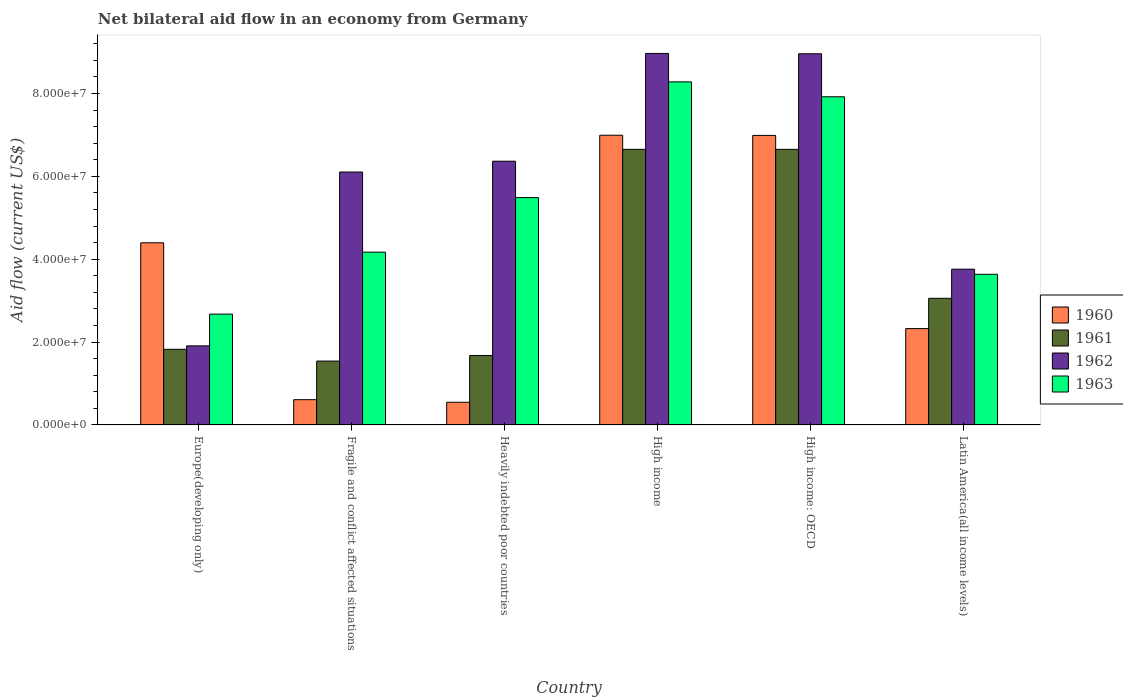How many groups of bars are there?
Your response must be concise. 6. How many bars are there on the 1st tick from the right?
Offer a terse response. 4. What is the label of the 6th group of bars from the left?
Provide a short and direct response. Latin America(all income levels). In how many cases, is the number of bars for a given country not equal to the number of legend labels?
Give a very brief answer. 0. What is the net bilateral aid flow in 1963 in Europe(developing only)?
Your response must be concise. 2.67e+07. Across all countries, what is the maximum net bilateral aid flow in 1962?
Offer a very short reply. 8.97e+07. Across all countries, what is the minimum net bilateral aid flow in 1961?
Ensure brevity in your answer.  1.54e+07. In which country was the net bilateral aid flow in 1960 maximum?
Offer a terse response. High income. In which country was the net bilateral aid flow in 1962 minimum?
Provide a succinct answer. Europe(developing only). What is the total net bilateral aid flow in 1960 in the graph?
Keep it short and to the point. 2.19e+08. What is the difference between the net bilateral aid flow in 1962 in Fragile and conflict affected situations and that in Latin America(all income levels)?
Your response must be concise. 2.34e+07. What is the difference between the net bilateral aid flow in 1961 in Fragile and conflict affected situations and the net bilateral aid flow in 1962 in High income: OECD?
Make the answer very short. -7.42e+07. What is the average net bilateral aid flow in 1961 per country?
Your answer should be very brief. 3.57e+07. What is the difference between the net bilateral aid flow of/in 1961 and net bilateral aid flow of/in 1960 in High income?
Your answer should be compact. -3.41e+06. What is the ratio of the net bilateral aid flow in 1962 in High income to that in Latin America(all income levels)?
Offer a terse response. 2.39. Is the difference between the net bilateral aid flow in 1961 in High income: OECD and Latin America(all income levels) greater than the difference between the net bilateral aid flow in 1960 in High income: OECD and Latin America(all income levels)?
Make the answer very short. No. What is the difference between the highest and the second highest net bilateral aid flow in 1960?
Keep it short and to the point. 2.60e+07. What is the difference between the highest and the lowest net bilateral aid flow in 1960?
Offer a very short reply. 6.44e+07. In how many countries, is the net bilateral aid flow in 1963 greater than the average net bilateral aid flow in 1963 taken over all countries?
Make the answer very short. 3. Is the sum of the net bilateral aid flow in 1963 in Heavily indebted poor countries and High income: OECD greater than the maximum net bilateral aid flow in 1961 across all countries?
Give a very brief answer. Yes. Is it the case that in every country, the sum of the net bilateral aid flow in 1960 and net bilateral aid flow in 1961 is greater than the sum of net bilateral aid flow in 1963 and net bilateral aid flow in 1962?
Make the answer very short. No. Is it the case that in every country, the sum of the net bilateral aid flow in 1963 and net bilateral aid flow in 1962 is greater than the net bilateral aid flow in 1960?
Ensure brevity in your answer.  Yes. Are all the bars in the graph horizontal?
Offer a terse response. No. What is the difference between two consecutive major ticks on the Y-axis?
Your answer should be compact. 2.00e+07. Does the graph contain grids?
Provide a succinct answer. No. Where does the legend appear in the graph?
Offer a terse response. Center right. How are the legend labels stacked?
Provide a succinct answer. Vertical. What is the title of the graph?
Your response must be concise. Net bilateral aid flow in an economy from Germany. Does "2004" appear as one of the legend labels in the graph?
Offer a very short reply. No. What is the label or title of the X-axis?
Provide a succinct answer. Country. What is the Aid flow (current US$) in 1960 in Europe(developing only)?
Offer a terse response. 4.40e+07. What is the Aid flow (current US$) in 1961 in Europe(developing only)?
Ensure brevity in your answer.  1.82e+07. What is the Aid flow (current US$) in 1962 in Europe(developing only)?
Your response must be concise. 1.91e+07. What is the Aid flow (current US$) in 1963 in Europe(developing only)?
Ensure brevity in your answer.  2.67e+07. What is the Aid flow (current US$) of 1960 in Fragile and conflict affected situations?
Make the answer very short. 6.09e+06. What is the Aid flow (current US$) of 1961 in Fragile and conflict affected situations?
Provide a succinct answer. 1.54e+07. What is the Aid flow (current US$) of 1962 in Fragile and conflict affected situations?
Give a very brief answer. 6.10e+07. What is the Aid flow (current US$) of 1963 in Fragile and conflict affected situations?
Provide a short and direct response. 4.17e+07. What is the Aid flow (current US$) of 1960 in Heavily indebted poor countries?
Keep it short and to the point. 5.47e+06. What is the Aid flow (current US$) of 1961 in Heavily indebted poor countries?
Offer a very short reply. 1.68e+07. What is the Aid flow (current US$) of 1962 in Heavily indebted poor countries?
Offer a very short reply. 6.36e+07. What is the Aid flow (current US$) in 1963 in Heavily indebted poor countries?
Provide a short and direct response. 5.49e+07. What is the Aid flow (current US$) of 1960 in High income?
Your answer should be compact. 6.99e+07. What is the Aid flow (current US$) of 1961 in High income?
Offer a terse response. 6.65e+07. What is the Aid flow (current US$) of 1962 in High income?
Offer a terse response. 8.97e+07. What is the Aid flow (current US$) of 1963 in High income?
Your answer should be very brief. 8.28e+07. What is the Aid flow (current US$) in 1960 in High income: OECD?
Your answer should be very brief. 6.99e+07. What is the Aid flow (current US$) of 1961 in High income: OECD?
Keep it short and to the point. 6.65e+07. What is the Aid flow (current US$) in 1962 in High income: OECD?
Provide a succinct answer. 8.96e+07. What is the Aid flow (current US$) in 1963 in High income: OECD?
Make the answer very short. 7.92e+07. What is the Aid flow (current US$) of 1960 in Latin America(all income levels)?
Provide a short and direct response. 2.32e+07. What is the Aid flow (current US$) in 1961 in Latin America(all income levels)?
Keep it short and to the point. 3.06e+07. What is the Aid flow (current US$) in 1962 in Latin America(all income levels)?
Give a very brief answer. 3.76e+07. What is the Aid flow (current US$) in 1963 in Latin America(all income levels)?
Give a very brief answer. 3.64e+07. Across all countries, what is the maximum Aid flow (current US$) of 1960?
Offer a very short reply. 6.99e+07. Across all countries, what is the maximum Aid flow (current US$) of 1961?
Your response must be concise. 6.65e+07. Across all countries, what is the maximum Aid flow (current US$) in 1962?
Your response must be concise. 8.97e+07. Across all countries, what is the maximum Aid flow (current US$) of 1963?
Your answer should be compact. 8.28e+07. Across all countries, what is the minimum Aid flow (current US$) in 1960?
Offer a terse response. 5.47e+06. Across all countries, what is the minimum Aid flow (current US$) in 1961?
Your answer should be very brief. 1.54e+07. Across all countries, what is the minimum Aid flow (current US$) of 1962?
Make the answer very short. 1.91e+07. Across all countries, what is the minimum Aid flow (current US$) of 1963?
Keep it short and to the point. 2.67e+07. What is the total Aid flow (current US$) in 1960 in the graph?
Make the answer very short. 2.19e+08. What is the total Aid flow (current US$) in 1961 in the graph?
Keep it short and to the point. 2.14e+08. What is the total Aid flow (current US$) in 1962 in the graph?
Your answer should be very brief. 3.61e+08. What is the total Aid flow (current US$) of 1963 in the graph?
Keep it short and to the point. 3.22e+08. What is the difference between the Aid flow (current US$) in 1960 in Europe(developing only) and that in Fragile and conflict affected situations?
Offer a terse response. 3.79e+07. What is the difference between the Aid flow (current US$) of 1961 in Europe(developing only) and that in Fragile and conflict affected situations?
Provide a succinct answer. 2.84e+06. What is the difference between the Aid flow (current US$) of 1962 in Europe(developing only) and that in Fragile and conflict affected situations?
Your answer should be compact. -4.20e+07. What is the difference between the Aid flow (current US$) of 1963 in Europe(developing only) and that in Fragile and conflict affected situations?
Your answer should be compact. -1.50e+07. What is the difference between the Aid flow (current US$) in 1960 in Europe(developing only) and that in Heavily indebted poor countries?
Your response must be concise. 3.85e+07. What is the difference between the Aid flow (current US$) of 1961 in Europe(developing only) and that in Heavily indebted poor countries?
Your answer should be compact. 1.49e+06. What is the difference between the Aid flow (current US$) of 1962 in Europe(developing only) and that in Heavily indebted poor countries?
Offer a very short reply. -4.46e+07. What is the difference between the Aid flow (current US$) in 1963 in Europe(developing only) and that in Heavily indebted poor countries?
Keep it short and to the point. -2.81e+07. What is the difference between the Aid flow (current US$) in 1960 in Europe(developing only) and that in High income?
Your answer should be compact. -2.60e+07. What is the difference between the Aid flow (current US$) in 1961 in Europe(developing only) and that in High income?
Keep it short and to the point. -4.83e+07. What is the difference between the Aid flow (current US$) in 1962 in Europe(developing only) and that in High income?
Give a very brief answer. -7.06e+07. What is the difference between the Aid flow (current US$) in 1963 in Europe(developing only) and that in High income?
Provide a short and direct response. -5.61e+07. What is the difference between the Aid flow (current US$) in 1960 in Europe(developing only) and that in High income: OECD?
Your answer should be very brief. -2.59e+07. What is the difference between the Aid flow (current US$) of 1961 in Europe(developing only) and that in High income: OECD?
Your response must be concise. -4.83e+07. What is the difference between the Aid flow (current US$) of 1962 in Europe(developing only) and that in High income: OECD?
Provide a short and direct response. -7.05e+07. What is the difference between the Aid flow (current US$) in 1963 in Europe(developing only) and that in High income: OECD?
Give a very brief answer. -5.25e+07. What is the difference between the Aid flow (current US$) in 1960 in Europe(developing only) and that in Latin America(all income levels)?
Offer a terse response. 2.07e+07. What is the difference between the Aid flow (current US$) in 1961 in Europe(developing only) and that in Latin America(all income levels)?
Provide a succinct answer. -1.23e+07. What is the difference between the Aid flow (current US$) in 1962 in Europe(developing only) and that in Latin America(all income levels)?
Your answer should be compact. -1.85e+07. What is the difference between the Aid flow (current US$) of 1963 in Europe(developing only) and that in Latin America(all income levels)?
Provide a short and direct response. -9.61e+06. What is the difference between the Aid flow (current US$) of 1960 in Fragile and conflict affected situations and that in Heavily indebted poor countries?
Ensure brevity in your answer.  6.20e+05. What is the difference between the Aid flow (current US$) in 1961 in Fragile and conflict affected situations and that in Heavily indebted poor countries?
Provide a succinct answer. -1.35e+06. What is the difference between the Aid flow (current US$) in 1962 in Fragile and conflict affected situations and that in Heavily indebted poor countries?
Make the answer very short. -2.61e+06. What is the difference between the Aid flow (current US$) of 1963 in Fragile and conflict affected situations and that in Heavily indebted poor countries?
Offer a terse response. -1.32e+07. What is the difference between the Aid flow (current US$) in 1960 in Fragile and conflict affected situations and that in High income?
Offer a terse response. -6.38e+07. What is the difference between the Aid flow (current US$) of 1961 in Fragile and conflict affected situations and that in High income?
Offer a terse response. -5.11e+07. What is the difference between the Aid flow (current US$) of 1962 in Fragile and conflict affected situations and that in High income?
Offer a terse response. -2.86e+07. What is the difference between the Aid flow (current US$) of 1963 in Fragile and conflict affected situations and that in High income?
Provide a succinct answer. -4.11e+07. What is the difference between the Aid flow (current US$) in 1960 in Fragile and conflict affected situations and that in High income: OECD?
Your response must be concise. -6.38e+07. What is the difference between the Aid flow (current US$) in 1961 in Fragile and conflict affected situations and that in High income: OECD?
Offer a very short reply. -5.11e+07. What is the difference between the Aid flow (current US$) of 1962 in Fragile and conflict affected situations and that in High income: OECD?
Offer a terse response. -2.85e+07. What is the difference between the Aid flow (current US$) in 1963 in Fragile and conflict affected situations and that in High income: OECD?
Offer a very short reply. -3.75e+07. What is the difference between the Aid flow (current US$) in 1960 in Fragile and conflict affected situations and that in Latin America(all income levels)?
Keep it short and to the point. -1.72e+07. What is the difference between the Aid flow (current US$) in 1961 in Fragile and conflict affected situations and that in Latin America(all income levels)?
Your answer should be compact. -1.52e+07. What is the difference between the Aid flow (current US$) of 1962 in Fragile and conflict affected situations and that in Latin America(all income levels)?
Give a very brief answer. 2.34e+07. What is the difference between the Aid flow (current US$) of 1963 in Fragile and conflict affected situations and that in Latin America(all income levels)?
Your answer should be compact. 5.35e+06. What is the difference between the Aid flow (current US$) in 1960 in Heavily indebted poor countries and that in High income?
Ensure brevity in your answer.  -6.44e+07. What is the difference between the Aid flow (current US$) of 1961 in Heavily indebted poor countries and that in High income?
Your answer should be very brief. -4.98e+07. What is the difference between the Aid flow (current US$) of 1962 in Heavily indebted poor countries and that in High income?
Keep it short and to the point. -2.60e+07. What is the difference between the Aid flow (current US$) of 1963 in Heavily indebted poor countries and that in High income?
Offer a terse response. -2.79e+07. What is the difference between the Aid flow (current US$) of 1960 in Heavily indebted poor countries and that in High income: OECD?
Your answer should be very brief. -6.44e+07. What is the difference between the Aid flow (current US$) in 1961 in Heavily indebted poor countries and that in High income: OECD?
Your response must be concise. -4.98e+07. What is the difference between the Aid flow (current US$) of 1962 in Heavily indebted poor countries and that in High income: OECD?
Your answer should be very brief. -2.59e+07. What is the difference between the Aid flow (current US$) in 1963 in Heavily indebted poor countries and that in High income: OECD?
Offer a terse response. -2.43e+07. What is the difference between the Aid flow (current US$) of 1960 in Heavily indebted poor countries and that in Latin America(all income levels)?
Make the answer very short. -1.78e+07. What is the difference between the Aid flow (current US$) of 1961 in Heavily indebted poor countries and that in Latin America(all income levels)?
Make the answer very short. -1.38e+07. What is the difference between the Aid flow (current US$) of 1962 in Heavily indebted poor countries and that in Latin America(all income levels)?
Provide a short and direct response. 2.61e+07. What is the difference between the Aid flow (current US$) in 1963 in Heavily indebted poor countries and that in Latin America(all income levels)?
Provide a succinct answer. 1.85e+07. What is the difference between the Aid flow (current US$) of 1963 in High income and that in High income: OECD?
Give a very brief answer. 3.60e+06. What is the difference between the Aid flow (current US$) in 1960 in High income and that in Latin America(all income levels)?
Your answer should be compact. 4.67e+07. What is the difference between the Aid flow (current US$) of 1961 in High income and that in Latin America(all income levels)?
Your answer should be very brief. 3.60e+07. What is the difference between the Aid flow (current US$) of 1962 in High income and that in Latin America(all income levels)?
Offer a very short reply. 5.21e+07. What is the difference between the Aid flow (current US$) of 1963 in High income and that in Latin America(all income levels)?
Your answer should be compact. 4.64e+07. What is the difference between the Aid flow (current US$) in 1960 in High income: OECD and that in Latin America(all income levels)?
Your answer should be compact. 4.66e+07. What is the difference between the Aid flow (current US$) of 1961 in High income: OECD and that in Latin America(all income levels)?
Keep it short and to the point. 3.60e+07. What is the difference between the Aid flow (current US$) in 1962 in High income: OECD and that in Latin America(all income levels)?
Keep it short and to the point. 5.20e+07. What is the difference between the Aid flow (current US$) of 1963 in High income: OECD and that in Latin America(all income levels)?
Provide a succinct answer. 4.28e+07. What is the difference between the Aid flow (current US$) of 1960 in Europe(developing only) and the Aid flow (current US$) of 1961 in Fragile and conflict affected situations?
Ensure brevity in your answer.  2.86e+07. What is the difference between the Aid flow (current US$) of 1960 in Europe(developing only) and the Aid flow (current US$) of 1962 in Fragile and conflict affected situations?
Offer a terse response. -1.71e+07. What is the difference between the Aid flow (current US$) of 1960 in Europe(developing only) and the Aid flow (current US$) of 1963 in Fragile and conflict affected situations?
Your answer should be compact. 2.26e+06. What is the difference between the Aid flow (current US$) in 1961 in Europe(developing only) and the Aid flow (current US$) in 1962 in Fragile and conflict affected situations?
Offer a terse response. -4.28e+07. What is the difference between the Aid flow (current US$) of 1961 in Europe(developing only) and the Aid flow (current US$) of 1963 in Fragile and conflict affected situations?
Offer a very short reply. -2.34e+07. What is the difference between the Aid flow (current US$) of 1962 in Europe(developing only) and the Aid flow (current US$) of 1963 in Fragile and conflict affected situations?
Your response must be concise. -2.26e+07. What is the difference between the Aid flow (current US$) of 1960 in Europe(developing only) and the Aid flow (current US$) of 1961 in Heavily indebted poor countries?
Offer a very short reply. 2.72e+07. What is the difference between the Aid flow (current US$) of 1960 in Europe(developing only) and the Aid flow (current US$) of 1962 in Heavily indebted poor countries?
Your answer should be compact. -1.97e+07. What is the difference between the Aid flow (current US$) of 1960 in Europe(developing only) and the Aid flow (current US$) of 1963 in Heavily indebted poor countries?
Make the answer very short. -1.09e+07. What is the difference between the Aid flow (current US$) of 1961 in Europe(developing only) and the Aid flow (current US$) of 1962 in Heavily indebted poor countries?
Keep it short and to the point. -4.54e+07. What is the difference between the Aid flow (current US$) of 1961 in Europe(developing only) and the Aid flow (current US$) of 1963 in Heavily indebted poor countries?
Give a very brief answer. -3.66e+07. What is the difference between the Aid flow (current US$) of 1962 in Europe(developing only) and the Aid flow (current US$) of 1963 in Heavily indebted poor countries?
Ensure brevity in your answer.  -3.58e+07. What is the difference between the Aid flow (current US$) of 1960 in Europe(developing only) and the Aid flow (current US$) of 1961 in High income?
Ensure brevity in your answer.  -2.26e+07. What is the difference between the Aid flow (current US$) in 1960 in Europe(developing only) and the Aid flow (current US$) in 1962 in High income?
Your response must be concise. -4.57e+07. What is the difference between the Aid flow (current US$) in 1960 in Europe(developing only) and the Aid flow (current US$) in 1963 in High income?
Offer a very short reply. -3.88e+07. What is the difference between the Aid flow (current US$) of 1961 in Europe(developing only) and the Aid flow (current US$) of 1962 in High income?
Provide a succinct answer. -7.14e+07. What is the difference between the Aid flow (current US$) in 1961 in Europe(developing only) and the Aid flow (current US$) in 1963 in High income?
Ensure brevity in your answer.  -6.46e+07. What is the difference between the Aid flow (current US$) in 1962 in Europe(developing only) and the Aid flow (current US$) in 1963 in High income?
Make the answer very short. -6.37e+07. What is the difference between the Aid flow (current US$) of 1960 in Europe(developing only) and the Aid flow (current US$) of 1961 in High income: OECD?
Make the answer very short. -2.26e+07. What is the difference between the Aid flow (current US$) of 1960 in Europe(developing only) and the Aid flow (current US$) of 1962 in High income: OECD?
Give a very brief answer. -4.56e+07. What is the difference between the Aid flow (current US$) of 1960 in Europe(developing only) and the Aid flow (current US$) of 1963 in High income: OECD?
Ensure brevity in your answer.  -3.52e+07. What is the difference between the Aid flow (current US$) of 1961 in Europe(developing only) and the Aid flow (current US$) of 1962 in High income: OECD?
Your answer should be very brief. -7.13e+07. What is the difference between the Aid flow (current US$) of 1961 in Europe(developing only) and the Aid flow (current US$) of 1963 in High income: OECD?
Ensure brevity in your answer.  -6.10e+07. What is the difference between the Aid flow (current US$) in 1962 in Europe(developing only) and the Aid flow (current US$) in 1963 in High income: OECD?
Keep it short and to the point. -6.01e+07. What is the difference between the Aid flow (current US$) of 1960 in Europe(developing only) and the Aid flow (current US$) of 1961 in Latin America(all income levels)?
Your answer should be compact. 1.34e+07. What is the difference between the Aid flow (current US$) in 1960 in Europe(developing only) and the Aid flow (current US$) in 1962 in Latin America(all income levels)?
Offer a very short reply. 6.37e+06. What is the difference between the Aid flow (current US$) of 1960 in Europe(developing only) and the Aid flow (current US$) of 1963 in Latin America(all income levels)?
Offer a very short reply. 7.61e+06. What is the difference between the Aid flow (current US$) of 1961 in Europe(developing only) and the Aid flow (current US$) of 1962 in Latin America(all income levels)?
Keep it short and to the point. -1.93e+07. What is the difference between the Aid flow (current US$) in 1961 in Europe(developing only) and the Aid flow (current US$) in 1963 in Latin America(all income levels)?
Keep it short and to the point. -1.81e+07. What is the difference between the Aid flow (current US$) in 1962 in Europe(developing only) and the Aid flow (current US$) in 1963 in Latin America(all income levels)?
Make the answer very short. -1.73e+07. What is the difference between the Aid flow (current US$) in 1960 in Fragile and conflict affected situations and the Aid flow (current US$) in 1961 in Heavily indebted poor countries?
Your answer should be compact. -1.07e+07. What is the difference between the Aid flow (current US$) in 1960 in Fragile and conflict affected situations and the Aid flow (current US$) in 1962 in Heavily indebted poor countries?
Your answer should be very brief. -5.76e+07. What is the difference between the Aid flow (current US$) in 1960 in Fragile and conflict affected situations and the Aid flow (current US$) in 1963 in Heavily indebted poor countries?
Your response must be concise. -4.88e+07. What is the difference between the Aid flow (current US$) in 1961 in Fragile and conflict affected situations and the Aid flow (current US$) in 1962 in Heavily indebted poor countries?
Ensure brevity in your answer.  -4.82e+07. What is the difference between the Aid flow (current US$) of 1961 in Fragile and conflict affected situations and the Aid flow (current US$) of 1963 in Heavily indebted poor countries?
Give a very brief answer. -3.95e+07. What is the difference between the Aid flow (current US$) of 1962 in Fragile and conflict affected situations and the Aid flow (current US$) of 1963 in Heavily indebted poor countries?
Keep it short and to the point. 6.17e+06. What is the difference between the Aid flow (current US$) of 1960 in Fragile and conflict affected situations and the Aid flow (current US$) of 1961 in High income?
Give a very brief answer. -6.04e+07. What is the difference between the Aid flow (current US$) in 1960 in Fragile and conflict affected situations and the Aid flow (current US$) in 1962 in High income?
Give a very brief answer. -8.36e+07. What is the difference between the Aid flow (current US$) in 1960 in Fragile and conflict affected situations and the Aid flow (current US$) in 1963 in High income?
Offer a very short reply. -7.67e+07. What is the difference between the Aid flow (current US$) in 1961 in Fragile and conflict affected situations and the Aid flow (current US$) in 1962 in High income?
Offer a terse response. -7.42e+07. What is the difference between the Aid flow (current US$) of 1961 in Fragile and conflict affected situations and the Aid flow (current US$) of 1963 in High income?
Ensure brevity in your answer.  -6.74e+07. What is the difference between the Aid flow (current US$) in 1962 in Fragile and conflict affected situations and the Aid flow (current US$) in 1963 in High income?
Keep it short and to the point. -2.18e+07. What is the difference between the Aid flow (current US$) in 1960 in Fragile and conflict affected situations and the Aid flow (current US$) in 1961 in High income: OECD?
Your response must be concise. -6.04e+07. What is the difference between the Aid flow (current US$) of 1960 in Fragile and conflict affected situations and the Aid flow (current US$) of 1962 in High income: OECD?
Offer a terse response. -8.35e+07. What is the difference between the Aid flow (current US$) in 1960 in Fragile and conflict affected situations and the Aid flow (current US$) in 1963 in High income: OECD?
Make the answer very short. -7.31e+07. What is the difference between the Aid flow (current US$) in 1961 in Fragile and conflict affected situations and the Aid flow (current US$) in 1962 in High income: OECD?
Offer a very short reply. -7.42e+07. What is the difference between the Aid flow (current US$) of 1961 in Fragile and conflict affected situations and the Aid flow (current US$) of 1963 in High income: OECD?
Offer a terse response. -6.38e+07. What is the difference between the Aid flow (current US$) of 1962 in Fragile and conflict affected situations and the Aid flow (current US$) of 1963 in High income: OECD?
Offer a very short reply. -1.82e+07. What is the difference between the Aid flow (current US$) in 1960 in Fragile and conflict affected situations and the Aid flow (current US$) in 1961 in Latin America(all income levels)?
Your answer should be compact. -2.45e+07. What is the difference between the Aid flow (current US$) in 1960 in Fragile and conflict affected situations and the Aid flow (current US$) in 1962 in Latin America(all income levels)?
Make the answer very short. -3.15e+07. What is the difference between the Aid flow (current US$) in 1960 in Fragile and conflict affected situations and the Aid flow (current US$) in 1963 in Latin America(all income levels)?
Make the answer very short. -3.03e+07. What is the difference between the Aid flow (current US$) of 1961 in Fragile and conflict affected situations and the Aid flow (current US$) of 1962 in Latin America(all income levels)?
Provide a succinct answer. -2.22e+07. What is the difference between the Aid flow (current US$) in 1961 in Fragile and conflict affected situations and the Aid flow (current US$) in 1963 in Latin America(all income levels)?
Give a very brief answer. -2.09e+07. What is the difference between the Aid flow (current US$) in 1962 in Fragile and conflict affected situations and the Aid flow (current US$) in 1963 in Latin America(all income levels)?
Your response must be concise. 2.47e+07. What is the difference between the Aid flow (current US$) in 1960 in Heavily indebted poor countries and the Aid flow (current US$) in 1961 in High income?
Give a very brief answer. -6.10e+07. What is the difference between the Aid flow (current US$) in 1960 in Heavily indebted poor countries and the Aid flow (current US$) in 1962 in High income?
Your answer should be compact. -8.42e+07. What is the difference between the Aid flow (current US$) in 1960 in Heavily indebted poor countries and the Aid flow (current US$) in 1963 in High income?
Offer a very short reply. -7.73e+07. What is the difference between the Aid flow (current US$) in 1961 in Heavily indebted poor countries and the Aid flow (current US$) in 1962 in High income?
Offer a terse response. -7.29e+07. What is the difference between the Aid flow (current US$) of 1961 in Heavily indebted poor countries and the Aid flow (current US$) of 1963 in High income?
Make the answer very short. -6.60e+07. What is the difference between the Aid flow (current US$) of 1962 in Heavily indebted poor countries and the Aid flow (current US$) of 1963 in High income?
Provide a succinct answer. -1.92e+07. What is the difference between the Aid flow (current US$) in 1960 in Heavily indebted poor countries and the Aid flow (current US$) in 1961 in High income: OECD?
Offer a very short reply. -6.10e+07. What is the difference between the Aid flow (current US$) in 1960 in Heavily indebted poor countries and the Aid flow (current US$) in 1962 in High income: OECD?
Keep it short and to the point. -8.41e+07. What is the difference between the Aid flow (current US$) in 1960 in Heavily indebted poor countries and the Aid flow (current US$) in 1963 in High income: OECD?
Offer a terse response. -7.37e+07. What is the difference between the Aid flow (current US$) of 1961 in Heavily indebted poor countries and the Aid flow (current US$) of 1962 in High income: OECD?
Make the answer very short. -7.28e+07. What is the difference between the Aid flow (current US$) in 1961 in Heavily indebted poor countries and the Aid flow (current US$) in 1963 in High income: OECD?
Your response must be concise. -6.24e+07. What is the difference between the Aid flow (current US$) of 1962 in Heavily indebted poor countries and the Aid flow (current US$) of 1963 in High income: OECD?
Provide a short and direct response. -1.56e+07. What is the difference between the Aid flow (current US$) in 1960 in Heavily indebted poor countries and the Aid flow (current US$) in 1961 in Latin America(all income levels)?
Your answer should be compact. -2.51e+07. What is the difference between the Aid flow (current US$) of 1960 in Heavily indebted poor countries and the Aid flow (current US$) of 1962 in Latin America(all income levels)?
Give a very brief answer. -3.21e+07. What is the difference between the Aid flow (current US$) of 1960 in Heavily indebted poor countries and the Aid flow (current US$) of 1963 in Latin America(all income levels)?
Keep it short and to the point. -3.09e+07. What is the difference between the Aid flow (current US$) of 1961 in Heavily indebted poor countries and the Aid flow (current US$) of 1962 in Latin America(all income levels)?
Ensure brevity in your answer.  -2.08e+07. What is the difference between the Aid flow (current US$) in 1961 in Heavily indebted poor countries and the Aid flow (current US$) in 1963 in Latin America(all income levels)?
Your answer should be compact. -1.96e+07. What is the difference between the Aid flow (current US$) of 1962 in Heavily indebted poor countries and the Aid flow (current US$) of 1963 in Latin America(all income levels)?
Provide a succinct answer. 2.73e+07. What is the difference between the Aid flow (current US$) of 1960 in High income and the Aid flow (current US$) of 1961 in High income: OECD?
Offer a very short reply. 3.41e+06. What is the difference between the Aid flow (current US$) in 1960 in High income and the Aid flow (current US$) in 1962 in High income: OECD?
Your answer should be very brief. -1.97e+07. What is the difference between the Aid flow (current US$) in 1960 in High income and the Aid flow (current US$) in 1963 in High income: OECD?
Make the answer very short. -9.28e+06. What is the difference between the Aid flow (current US$) in 1961 in High income and the Aid flow (current US$) in 1962 in High income: OECD?
Offer a very short reply. -2.31e+07. What is the difference between the Aid flow (current US$) in 1961 in High income and the Aid flow (current US$) in 1963 in High income: OECD?
Keep it short and to the point. -1.27e+07. What is the difference between the Aid flow (current US$) in 1962 in High income and the Aid flow (current US$) in 1963 in High income: OECD?
Provide a short and direct response. 1.05e+07. What is the difference between the Aid flow (current US$) of 1960 in High income and the Aid flow (current US$) of 1961 in Latin America(all income levels)?
Provide a short and direct response. 3.94e+07. What is the difference between the Aid flow (current US$) in 1960 in High income and the Aid flow (current US$) in 1962 in Latin America(all income levels)?
Make the answer very short. 3.23e+07. What is the difference between the Aid flow (current US$) in 1960 in High income and the Aid flow (current US$) in 1963 in Latin America(all income levels)?
Offer a very short reply. 3.36e+07. What is the difference between the Aid flow (current US$) of 1961 in High income and the Aid flow (current US$) of 1962 in Latin America(all income levels)?
Keep it short and to the point. 2.89e+07. What is the difference between the Aid flow (current US$) of 1961 in High income and the Aid flow (current US$) of 1963 in Latin America(all income levels)?
Provide a succinct answer. 3.02e+07. What is the difference between the Aid flow (current US$) in 1962 in High income and the Aid flow (current US$) in 1963 in Latin America(all income levels)?
Provide a short and direct response. 5.33e+07. What is the difference between the Aid flow (current US$) of 1960 in High income: OECD and the Aid flow (current US$) of 1961 in Latin America(all income levels)?
Your answer should be compact. 3.93e+07. What is the difference between the Aid flow (current US$) in 1960 in High income: OECD and the Aid flow (current US$) in 1962 in Latin America(all income levels)?
Provide a succinct answer. 3.23e+07. What is the difference between the Aid flow (current US$) in 1960 in High income: OECD and the Aid flow (current US$) in 1963 in Latin America(all income levels)?
Offer a terse response. 3.35e+07. What is the difference between the Aid flow (current US$) of 1961 in High income: OECD and the Aid flow (current US$) of 1962 in Latin America(all income levels)?
Make the answer very short. 2.89e+07. What is the difference between the Aid flow (current US$) in 1961 in High income: OECD and the Aid flow (current US$) in 1963 in Latin America(all income levels)?
Your response must be concise. 3.02e+07. What is the difference between the Aid flow (current US$) in 1962 in High income: OECD and the Aid flow (current US$) in 1963 in Latin America(all income levels)?
Keep it short and to the point. 5.32e+07. What is the average Aid flow (current US$) in 1960 per country?
Give a very brief answer. 3.64e+07. What is the average Aid flow (current US$) in 1961 per country?
Your response must be concise. 3.57e+07. What is the average Aid flow (current US$) in 1962 per country?
Your response must be concise. 6.01e+07. What is the average Aid flow (current US$) in 1963 per country?
Offer a terse response. 5.36e+07. What is the difference between the Aid flow (current US$) in 1960 and Aid flow (current US$) in 1961 in Europe(developing only)?
Your answer should be compact. 2.57e+07. What is the difference between the Aid flow (current US$) of 1960 and Aid flow (current US$) of 1962 in Europe(developing only)?
Offer a very short reply. 2.49e+07. What is the difference between the Aid flow (current US$) of 1960 and Aid flow (current US$) of 1963 in Europe(developing only)?
Provide a succinct answer. 1.72e+07. What is the difference between the Aid flow (current US$) of 1961 and Aid flow (current US$) of 1962 in Europe(developing only)?
Give a very brief answer. -8.30e+05. What is the difference between the Aid flow (current US$) of 1961 and Aid flow (current US$) of 1963 in Europe(developing only)?
Provide a short and direct response. -8.49e+06. What is the difference between the Aid flow (current US$) in 1962 and Aid flow (current US$) in 1963 in Europe(developing only)?
Provide a succinct answer. -7.66e+06. What is the difference between the Aid flow (current US$) of 1960 and Aid flow (current US$) of 1961 in Fragile and conflict affected situations?
Offer a terse response. -9.32e+06. What is the difference between the Aid flow (current US$) in 1960 and Aid flow (current US$) in 1962 in Fragile and conflict affected situations?
Your response must be concise. -5.50e+07. What is the difference between the Aid flow (current US$) in 1960 and Aid flow (current US$) in 1963 in Fragile and conflict affected situations?
Offer a terse response. -3.56e+07. What is the difference between the Aid flow (current US$) in 1961 and Aid flow (current US$) in 1962 in Fragile and conflict affected situations?
Ensure brevity in your answer.  -4.56e+07. What is the difference between the Aid flow (current US$) in 1961 and Aid flow (current US$) in 1963 in Fragile and conflict affected situations?
Your answer should be compact. -2.63e+07. What is the difference between the Aid flow (current US$) in 1962 and Aid flow (current US$) in 1963 in Fragile and conflict affected situations?
Provide a short and direct response. 1.93e+07. What is the difference between the Aid flow (current US$) of 1960 and Aid flow (current US$) of 1961 in Heavily indebted poor countries?
Provide a short and direct response. -1.13e+07. What is the difference between the Aid flow (current US$) in 1960 and Aid flow (current US$) in 1962 in Heavily indebted poor countries?
Offer a very short reply. -5.82e+07. What is the difference between the Aid flow (current US$) in 1960 and Aid flow (current US$) in 1963 in Heavily indebted poor countries?
Your answer should be very brief. -4.94e+07. What is the difference between the Aid flow (current US$) of 1961 and Aid flow (current US$) of 1962 in Heavily indebted poor countries?
Offer a terse response. -4.69e+07. What is the difference between the Aid flow (current US$) of 1961 and Aid flow (current US$) of 1963 in Heavily indebted poor countries?
Your response must be concise. -3.81e+07. What is the difference between the Aid flow (current US$) in 1962 and Aid flow (current US$) in 1963 in Heavily indebted poor countries?
Offer a terse response. 8.78e+06. What is the difference between the Aid flow (current US$) of 1960 and Aid flow (current US$) of 1961 in High income?
Give a very brief answer. 3.41e+06. What is the difference between the Aid flow (current US$) in 1960 and Aid flow (current US$) in 1962 in High income?
Make the answer very short. -1.97e+07. What is the difference between the Aid flow (current US$) in 1960 and Aid flow (current US$) in 1963 in High income?
Provide a short and direct response. -1.29e+07. What is the difference between the Aid flow (current US$) of 1961 and Aid flow (current US$) of 1962 in High income?
Make the answer very short. -2.32e+07. What is the difference between the Aid flow (current US$) in 1961 and Aid flow (current US$) in 1963 in High income?
Your answer should be compact. -1.63e+07. What is the difference between the Aid flow (current US$) in 1962 and Aid flow (current US$) in 1963 in High income?
Keep it short and to the point. 6.86e+06. What is the difference between the Aid flow (current US$) of 1960 and Aid flow (current US$) of 1961 in High income: OECD?
Ensure brevity in your answer.  3.37e+06. What is the difference between the Aid flow (current US$) in 1960 and Aid flow (current US$) in 1962 in High income: OECD?
Keep it short and to the point. -1.97e+07. What is the difference between the Aid flow (current US$) of 1960 and Aid flow (current US$) of 1963 in High income: OECD?
Your answer should be very brief. -9.32e+06. What is the difference between the Aid flow (current US$) in 1961 and Aid flow (current US$) in 1962 in High income: OECD?
Your answer should be very brief. -2.31e+07. What is the difference between the Aid flow (current US$) in 1961 and Aid flow (current US$) in 1963 in High income: OECD?
Offer a very short reply. -1.27e+07. What is the difference between the Aid flow (current US$) of 1962 and Aid flow (current US$) of 1963 in High income: OECD?
Offer a terse response. 1.04e+07. What is the difference between the Aid flow (current US$) in 1960 and Aid flow (current US$) in 1961 in Latin America(all income levels)?
Offer a terse response. -7.31e+06. What is the difference between the Aid flow (current US$) in 1960 and Aid flow (current US$) in 1962 in Latin America(all income levels)?
Offer a terse response. -1.43e+07. What is the difference between the Aid flow (current US$) in 1960 and Aid flow (current US$) in 1963 in Latin America(all income levels)?
Offer a very short reply. -1.31e+07. What is the difference between the Aid flow (current US$) of 1961 and Aid flow (current US$) of 1962 in Latin America(all income levels)?
Keep it short and to the point. -7.03e+06. What is the difference between the Aid flow (current US$) of 1961 and Aid flow (current US$) of 1963 in Latin America(all income levels)?
Your response must be concise. -5.79e+06. What is the difference between the Aid flow (current US$) in 1962 and Aid flow (current US$) in 1963 in Latin America(all income levels)?
Keep it short and to the point. 1.24e+06. What is the ratio of the Aid flow (current US$) of 1960 in Europe(developing only) to that in Fragile and conflict affected situations?
Keep it short and to the point. 7.22. What is the ratio of the Aid flow (current US$) in 1961 in Europe(developing only) to that in Fragile and conflict affected situations?
Provide a short and direct response. 1.18. What is the ratio of the Aid flow (current US$) in 1962 in Europe(developing only) to that in Fragile and conflict affected situations?
Provide a short and direct response. 0.31. What is the ratio of the Aid flow (current US$) of 1963 in Europe(developing only) to that in Fragile and conflict affected situations?
Your answer should be very brief. 0.64. What is the ratio of the Aid flow (current US$) of 1960 in Europe(developing only) to that in Heavily indebted poor countries?
Provide a succinct answer. 8.04. What is the ratio of the Aid flow (current US$) in 1961 in Europe(developing only) to that in Heavily indebted poor countries?
Offer a very short reply. 1.09. What is the ratio of the Aid flow (current US$) in 1962 in Europe(developing only) to that in Heavily indebted poor countries?
Provide a short and direct response. 0.3. What is the ratio of the Aid flow (current US$) of 1963 in Europe(developing only) to that in Heavily indebted poor countries?
Make the answer very short. 0.49. What is the ratio of the Aid flow (current US$) of 1960 in Europe(developing only) to that in High income?
Make the answer very short. 0.63. What is the ratio of the Aid flow (current US$) of 1961 in Europe(developing only) to that in High income?
Give a very brief answer. 0.27. What is the ratio of the Aid flow (current US$) in 1962 in Europe(developing only) to that in High income?
Make the answer very short. 0.21. What is the ratio of the Aid flow (current US$) of 1963 in Europe(developing only) to that in High income?
Offer a terse response. 0.32. What is the ratio of the Aid flow (current US$) in 1960 in Europe(developing only) to that in High income: OECD?
Your answer should be very brief. 0.63. What is the ratio of the Aid flow (current US$) of 1961 in Europe(developing only) to that in High income: OECD?
Make the answer very short. 0.27. What is the ratio of the Aid flow (current US$) in 1962 in Europe(developing only) to that in High income: OECD?
Your answer should be compact. 0.21. What is the ratio of the Aid flow (current US$) of 1963 in Europe(developing only) to that in High income: OECD?
Your response must be concise. 0.34. What is the ratio of the Aid flow (current US$) of 1960 in Europe(developing only) to that in Latin America(all income levels)?
Your answer should be compact. 1.89. What is the ratio of the Aid flow (current US$) in 1961 in Europe(developing only) to that in Latin America(all income levels)?
Offer a very short reply. 0.6. What is the ratio of the Aid flow (current US$) of 1962 in Europe(developing only) to that in Latin America(all income levels)?
Your answer should be very brief. 0.51. What is the ratio of the Aid flow (current US$) in 1963 in Europe(developing only) to that in Latin America(all income levels)?
Give a very brief answer. 0.74. What is the ratio of the Aid flow (current US$) of 1960 in Fragile and conflict affected situations to that in Heavily indebted poor countries?
Keep it short and to the point. 1.11. What is the ratio of the Aid flow (current US$) of 1961 in Fragile and conflict affected situations to that in Heavily indebted poor countries?
Ensure brevity in your answer.  0.92. What is the ratio of the Aid flow (current US$) in 1962 in Fragile and conflict affected situations to that in Heavily indebted poor countries?
Keep it short and to the point. 0.96. What is the ratio of the Aid flow (current US$) in 1963 in Fragile and conflict affected situations to that in Heavily indebted poor countries?
Ensure brevity in your answer.  0.76. What is the ratio of the Aid flow (current US$) in 1960 in Fragile and conflict affected situations to that in High income?
Offer a very short reply. 0.09. What is the ratio of the Aid flow (current US$) of 1961 in Fragile and conflict affected situations to that in High income?
Offer a very short reply. 0.23. What is the ratio of the Aid flow (current US$) of 1962 in Fragile and conflict affected situations to that in High income?
Give a very brief answer. 0.68. What is the ratio of the Aid flow (current US$) in 1963 in Fragile and conflict affected situations to that in High income?
Offer a very short reply. 0.5. What is the ratio of the Aid flow (current US$) of 1960 in Fragile and conflict affected situations to that in High income: OECD?
Your response must be concise. 0.09. What is the ratio of the Aid flow (current US$) in 1961 in Fragile and conflict affected situations to that in High income: OECD?
Give a very brief answer. 0.23. What is the ratio of the Aid flow (current US$) of 1962 in Fragile and conflict affected situations to that in High income: OECD?
Provide a succinct answer. 0.68. What is the ratio of the Aid flow (current US$) in 1963 in Fragile and conflict affected situations to that in High income: OECD?
Your answer should be very brief. 0.53. What is the ratio of the Aid flow (current US$) of 1960 in Fragile and conflict affected situations to that in Latin America(all income levels)?
Your answer should be very brief. 0.26. What is the ratio of the Aid flow (current US$) of 1961 in Fragile and conflict affected situations to that in Latin America(all income levels)?
Keep it short and to the point. 0.5. What is the ratio of the Aid flow (current US$) of 1962 in Fragile and conflict affected situations to that in Latin America(all income levels)?
Your response must be concise. 1.62. What is the ratio of the Aid flow (current US$) of 1963 in Fragile and conflict affected situations to that in Latin America(all income levels)?
Provide a succinct answer. 1.15. What is the ratio of the Aid flow (current US$) of 1960 in Heavily indebted poor countries to that in High income?
Offer a terse response. 0.08. What is the ratio of the Aid flow (current US$) in 1961 in Heavily indebted poor countries to that in High income?
Make the answer very short. 0.25. What is the ratio of the Aid flow (current US$) of 1962 in Heavily indebted poor countries to that in High income?
Your response must be concise. 0.71. What is the ratio of the Aid flow (current US$) of 1963 in Heavily indebted poor countries to that in High income?
Provide a succinct answer. 0.66. What is the ratio of the Aid flow (current US$) of 1960 in Heavily indebted poor countries to that in High income: OECD?
Ensure brevity in your answer.  0.08. What is the ratio of the Aid flow (current US$) in 1961 in Heavily indebted poor countries to that in High income: OECD?
Ensure brevity in your answer.  0.25. What is the ratio of the Aid flow (current US$) of 1962 in Heavily indebted poor countries to that in High income: OECD?
Keep it short and to the point. 0.71. What is the ratio of the Aid flow (current US$) in 1963 in Heavily indebted poor countries to that in High income: OECD?
Make the answer very short. 0.69. What is the ratio of the Aid flow (current US$) in 1960 in Heavily indebted poor countries to that in Latin America(all income levels)?
Offer a terse response. 0.24. What is the ratio of the Aid flow (current US$) in 1961 in Heavily indebted poor countries to that in Latin America(all income levels)?
Offer a terse response. 0.55. What is the ratio of the Aid flow (current US$) of 1962 in Heavily indebted poor countries to that in Latin America(all income levels)?
Provide a short and direct response. 1.69. What is the ratio of the Aid flow (current US$) of 1963 in Heavily indebted poor countries to that in Latin America(all income levels)?
Your answer should be compact. 1.51. What is the ratio of the Aid flow (current US$) in 1960 in High income to that in High income: OECD?
Offer a very short reply. 1. What is the ratio of the Aid flow (current US$) of 1963 in High income to that in High income: OECD?
Provide a succinct answer. 1.05. What is the ratio of the Aid flow (current US$) of 1960 in High income to that in Latin America(all income levels)?
Give a very brief answer. 3.01. What is the ratio of the Aid flow (current US$) in 1961 in High income to that in Latin America(all income levels)?
Your answer should be very brief. 2.18. What is the ratio of the Aid flow (current US$) of 1962 in High income to that in Latin America(all income levels)?
Ensure brevity in your answer.  2.39. What is the ratio of the Aid flow (current US$) of 1963 in High income to that in Latin America(all income levels)?
Your answer should be very brief. 2.28. What is the ratio of the Aid flow (current US$) in 1960 in High income: OECD to that in Latin America(all income levels)?
Provide a succinct answer. 3.01. What is the ratio of the Aid flow (current US$) of 1961 in High income: OECD to that in Latin America(all income levels)?
Your answer should be very brief. 2.18. What is the ratio of the Aid flow (current US$) of 1962 in High income: OECD to that in Latin America(all income levels)?
Keep it short and to the point. 2.38. What is the ratio of the Aid flow (current US$) of 1963 in High income: OECD to that in Latin America(all income levels)?
Offer a terse response. 2.18. What is the difference between the highest and the second highest Aid flow (current US$) in 1960?
Keep it short and to the point. 4.00e+04. What is the difference between the highest and the second highest Aid flow (current US$) of 1961?
Give a very brief answer. 0. What is the difference between the highest and the second highest Aid flow (current US$) of 1963?
Keep it short and to the point. 3.60e+06. What is the difference between the highest and the lowest Aid flow (current US$) of 1960?
Keep it short and to the point. 6.44e+07. What is the difference between the highest and the lowest Aid flow (current US$) in 1961?
Your response must be concise. 5.11e+07. What is the difference between the highest and the lowest Aid flow (current US$) of 1962?
Keep it short and to the point. 7.06e+07. What is the difference between the highest and the lowest Aid flow (current US$) in 1963?
Provide a succinct answer. 5.61e+07. 